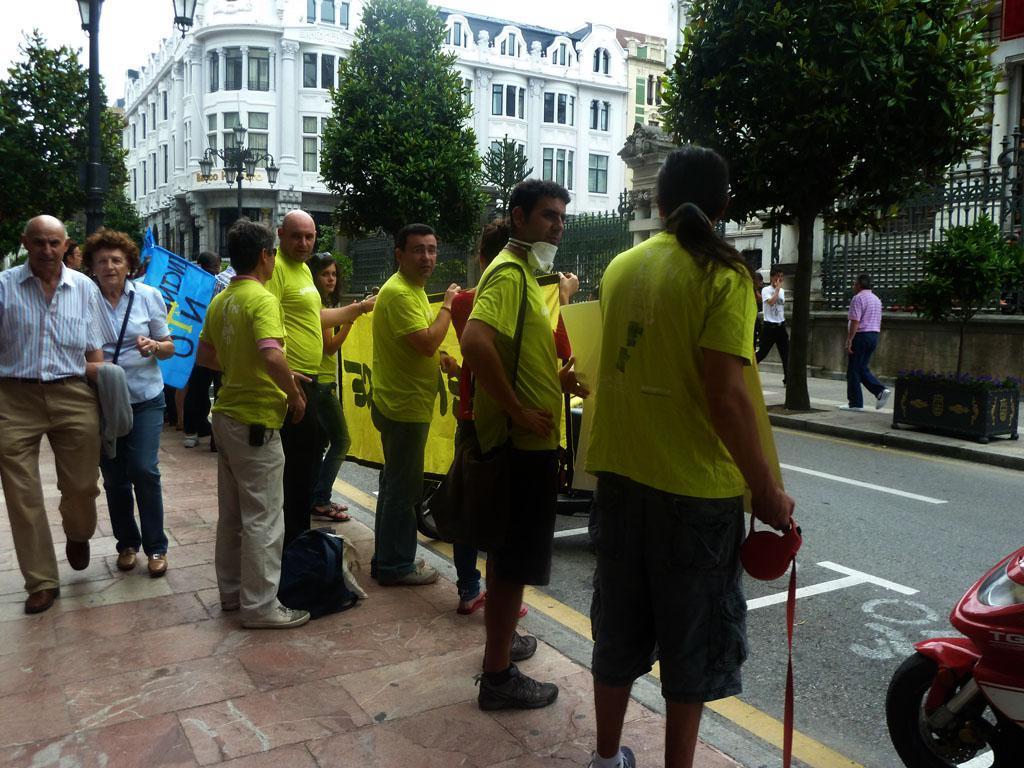Could you give a brief overview of what you see in this image? In the picture we can see some people are standing on the path holding the banner and behind them, we can see two people are walking and in the background, we can see the trees, building and a part of the sky. 